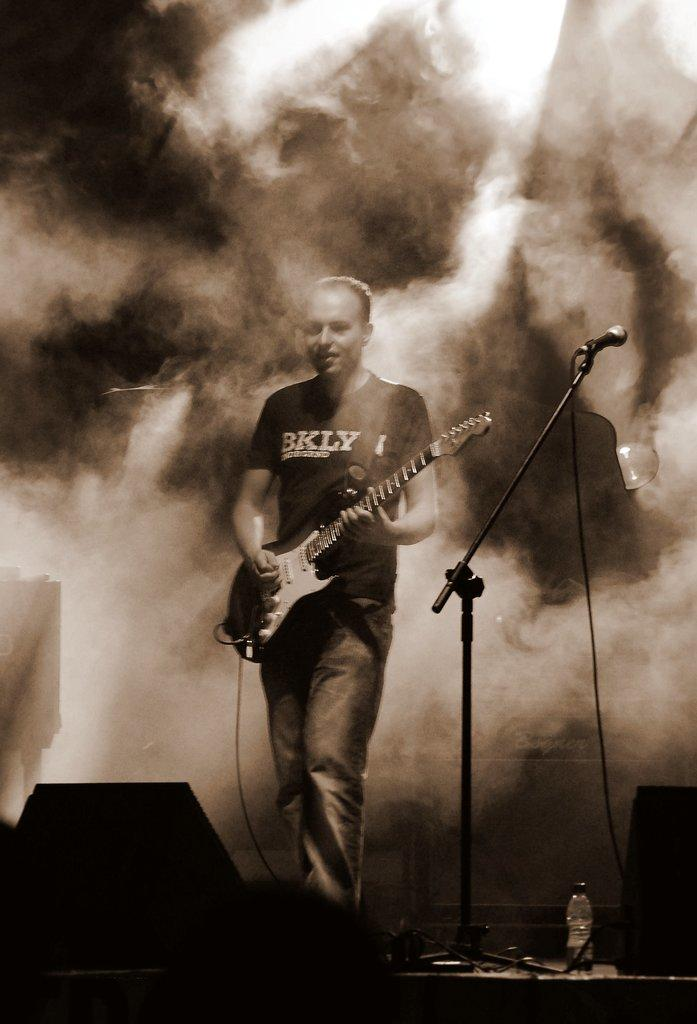What is the main subject of the image? The main subject of the image is a man standing in the middle. What is the man holding in the image? The man is holding a music instrument. Can you describe any other objects in the image? Yes, there is a microphone in the image. What is the color of the microphone? The microphone is black in color. How much money is the man holding in the image? There is no money visible in the image; the man is holding a music instrument. What type of glove is the man wearing in the image? The man is not wearing a glove in the image; he is holding a music instrument. 